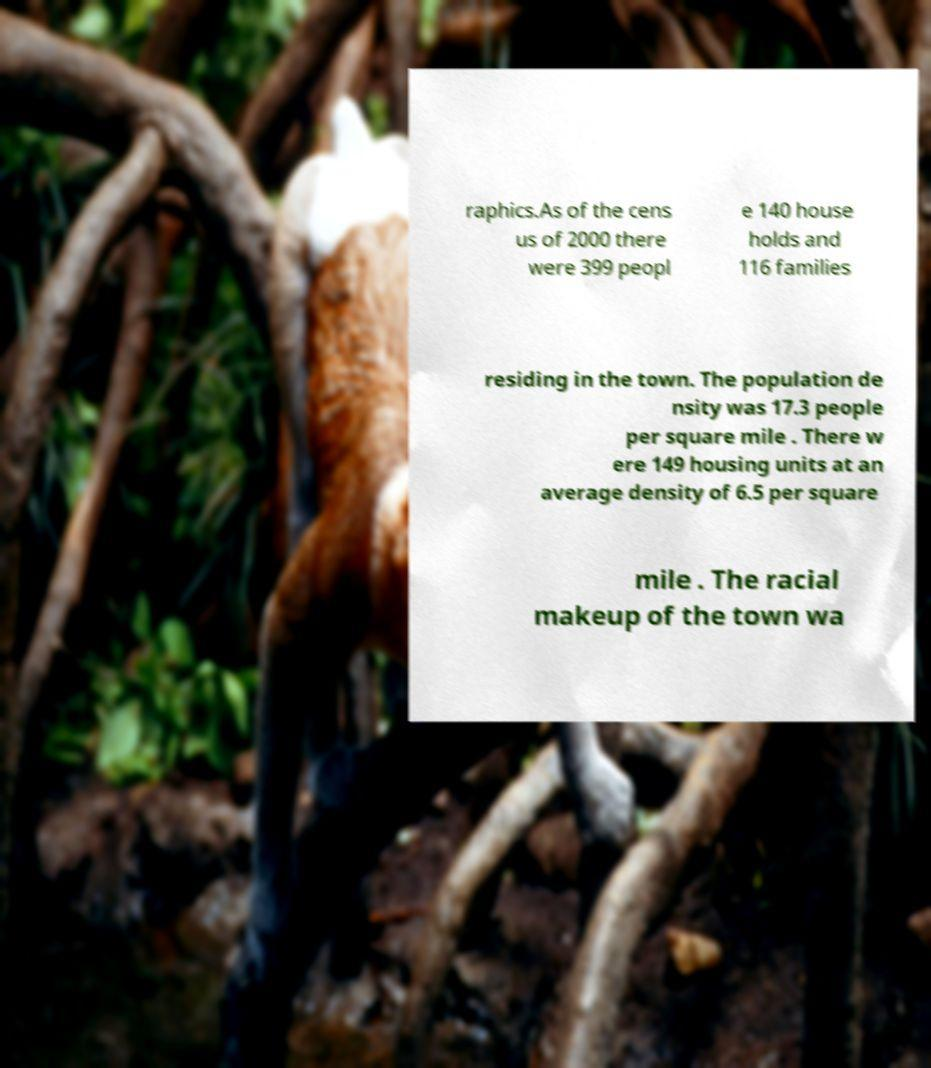I need the written content from this picture converted into text. Can you do that? raphics.As of the cens us of 2000 there were 399 peopl e 140 house holds and 116 families residing in the town. The population de nsity was 17.3 people per square mile . There w ere 149 housing units at an average density of 6.5 per square mile . The racial makeup of the town wa 